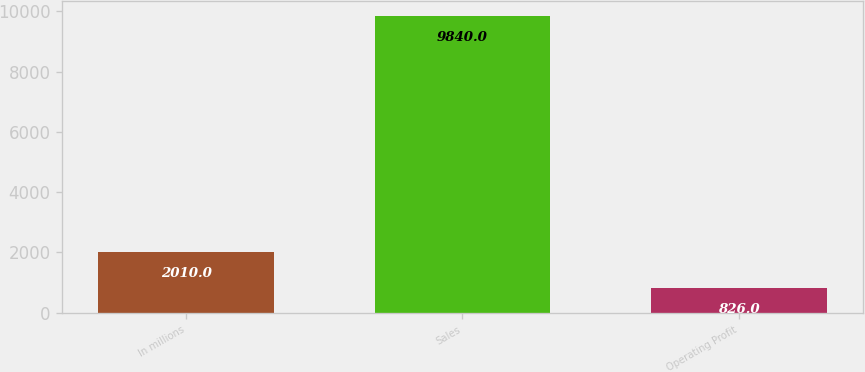<chart> <loc_0><loc_0><loc_500><loc_500><bar_chart><fcel>In millions<fcel>Sales<fcel>Operating Profit<nl><fcel>2010<fcel>9840<fcel>826<nl></chart> 